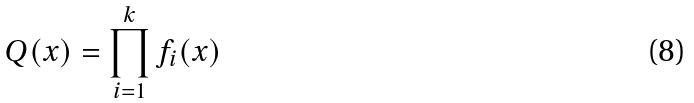Convert formula to latex. <formula><loc_0><loc_0><loc_500><loc_500>Q ( x ) = \prod _ { i = 1 } ^ { k } f _ { i } ( x )</formula> 